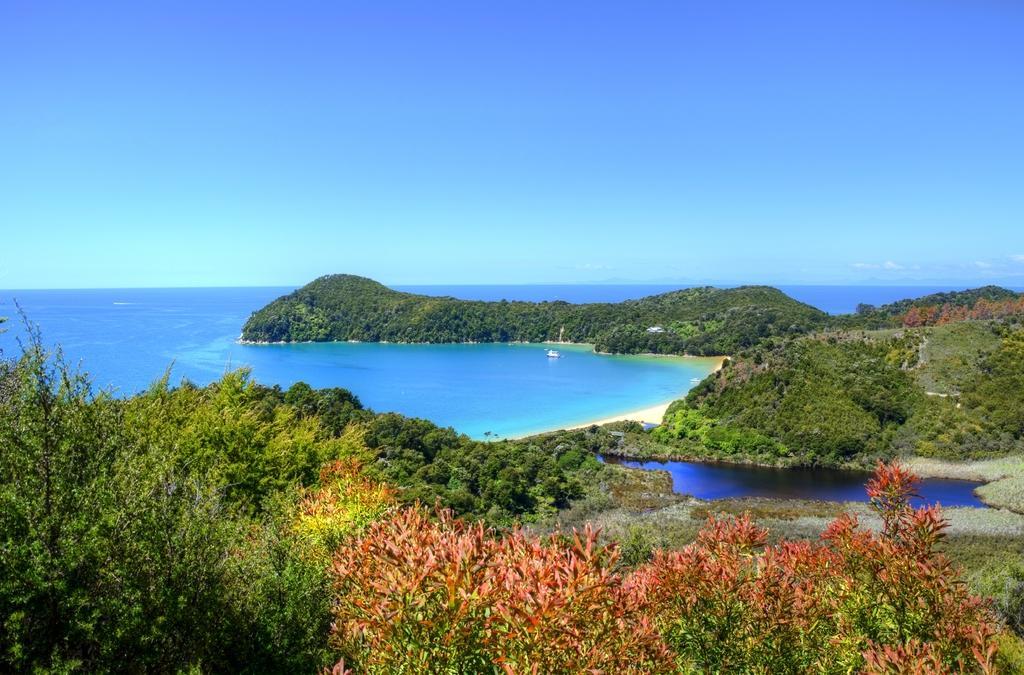Describe this image in one or two sentences. This picture is clicked outside the city. In the foreground we can see the plants. In the center there is a water body. In the background there is a sky. 